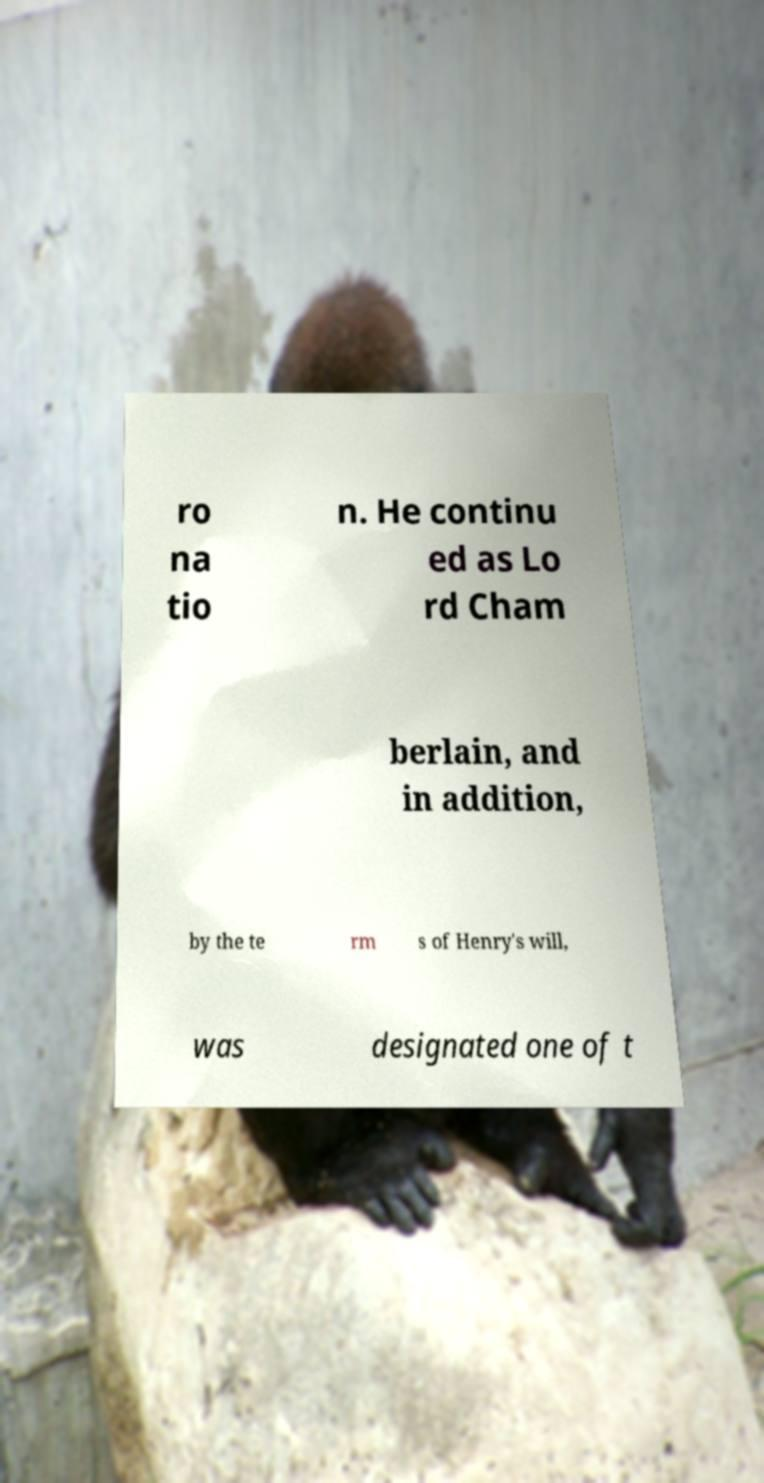There's text embedded in this image that I need extracted. Can you transcribe it verbatim? ro na tio n. He continu ed as Lo rd Cham berlain, and in addition, by the te rm s of Henry's will, was designated one of t 